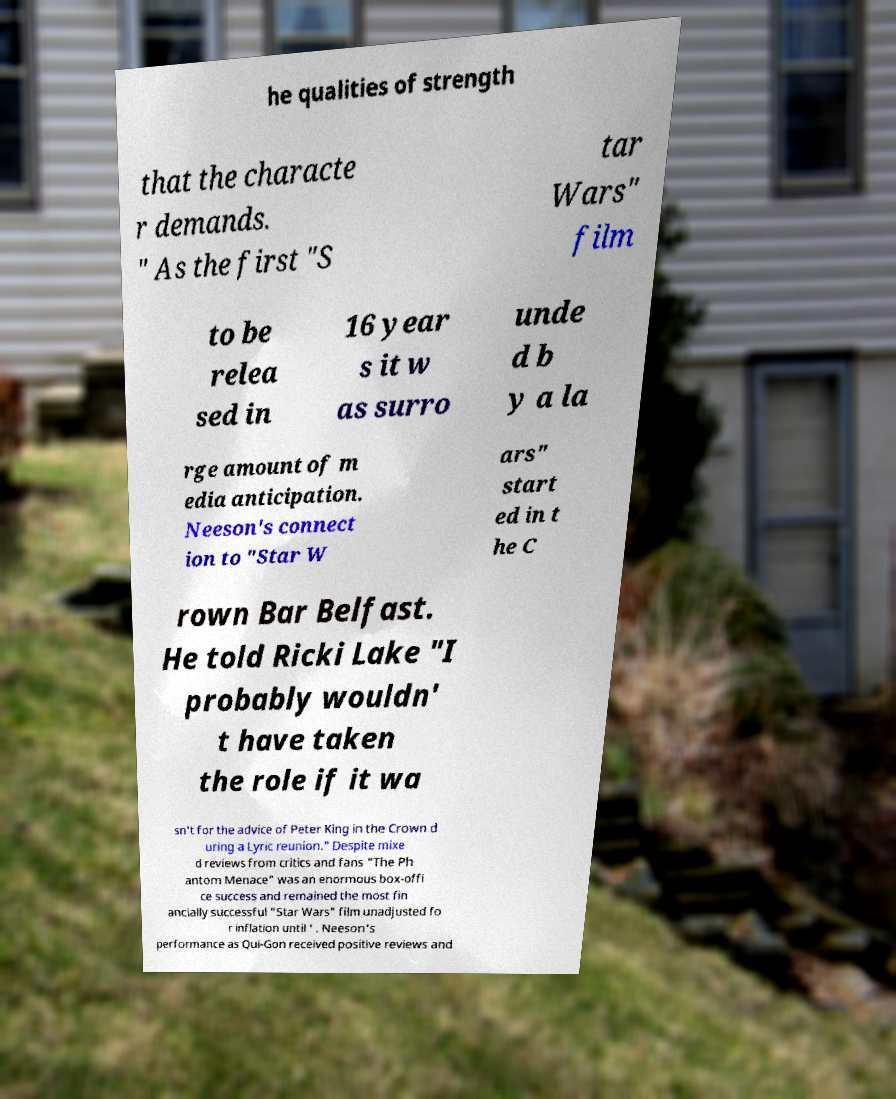Please read and relay the text visible in this image. What does it say? he qualities of strength that the characte r demands. " As the first "S tar Wars" film to be relea sed in 16 year s it w as surro unde d b y a la rge amount of m edia anticipation. Neeson's connect ion to "Star W ars" start ed in t he C rown Bar Belfast. He told Ricki Lake "I probably wouldn' t have taken the role if it wa sn't for the advice of Peter King in the Crown d uring a Lyric reunion." Despite mixe d reviews from critics and fans "The Ph antom Menace" was an enormous box-offi ce success and remained the most fin ancially successful "Star Wars" film unadjusted fo r inflation until ' . Neeson's performance as Qui-Gon received positive reviews and 